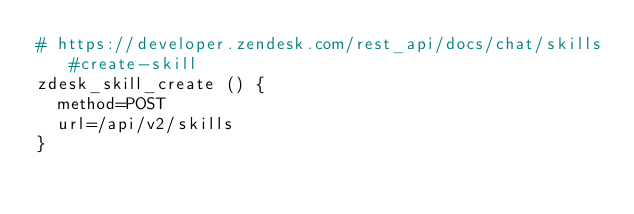Convert code to text. <code><loc_0><loc_0><loc_500><loc_500><_Bash_># https://developer.zendesk.com/rest_api/docs/chat/skills#create-skill
zdesk_skill_create () {
  method=POST
  url=/api/v2/skills
}</code> 